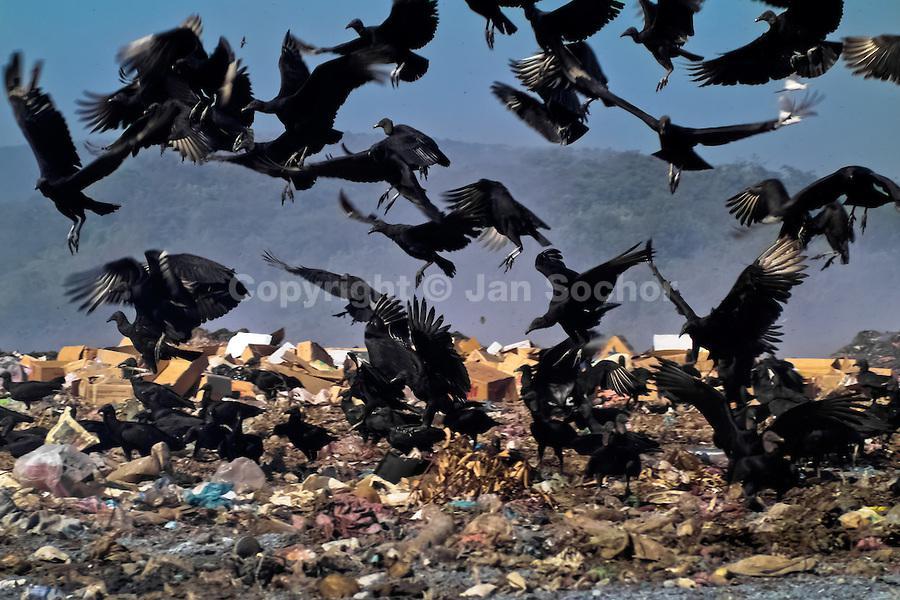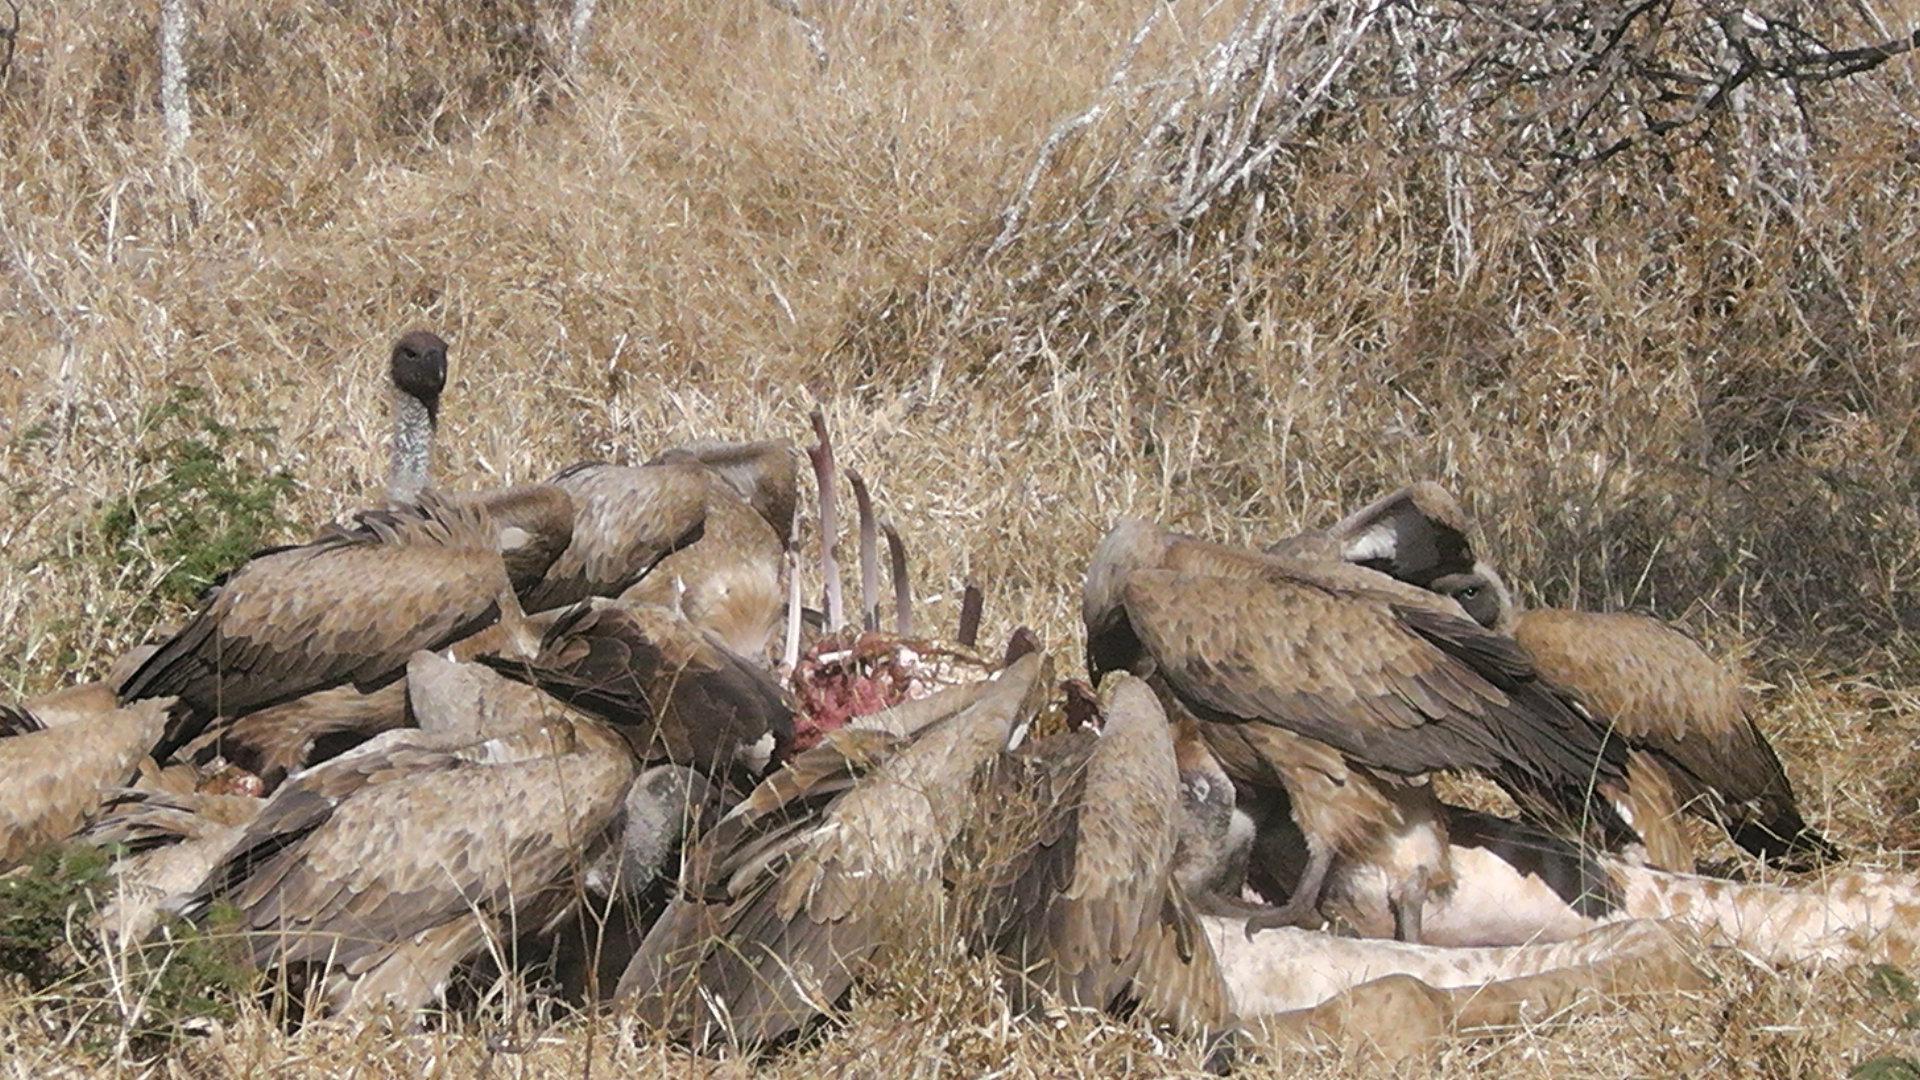The first image is the image on the left, the second image is the image on the right. Analyze the images presented: Is the assertion "There are no more than five birds in one of the images." valid? Answer yes or no. No. 